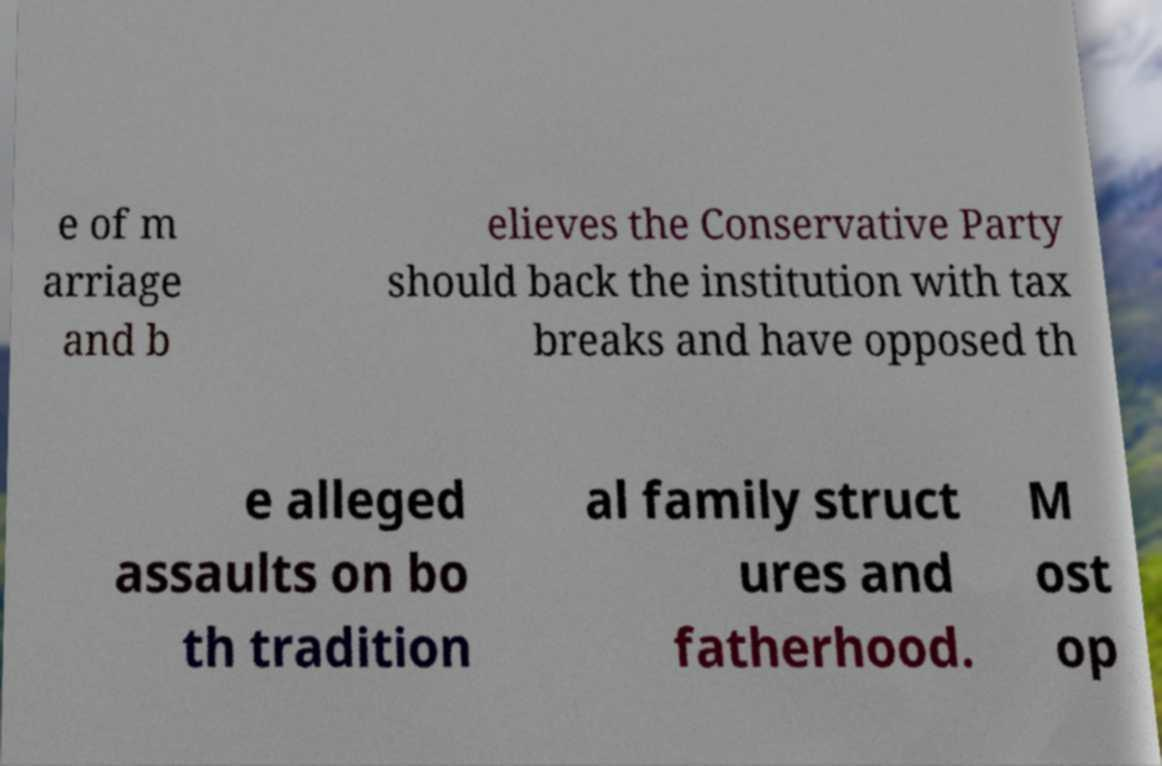For documentation purposes, I need the text within this image transcribed. Could you provide that? e of m arriage and b elieves the Conservative Party should back the institution with tax breaks and have opposed th e alleged assaults on bo th tradition al family struct ures and fatherhood. M ost op 